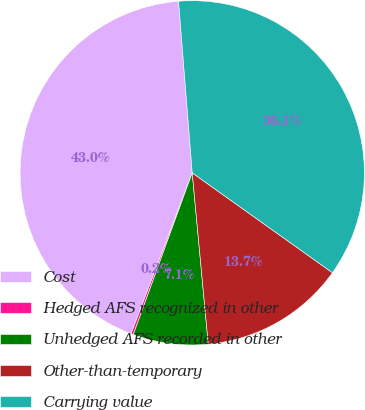Convert chart. <chart><loc_0><loc_0><loc_500><loc_500><pie_chart><fcel>Cost<fcel>Hedged AFS recognized in other<fcel>Unhedged AFS recorded in other<fcel>Other-than-temporary<fcel>Carrying value<nl><fcel>42.95%<fcel>0.22%<fcel>7.05%<fcel>13.66%<fcel>36.12%<nl></chart> 